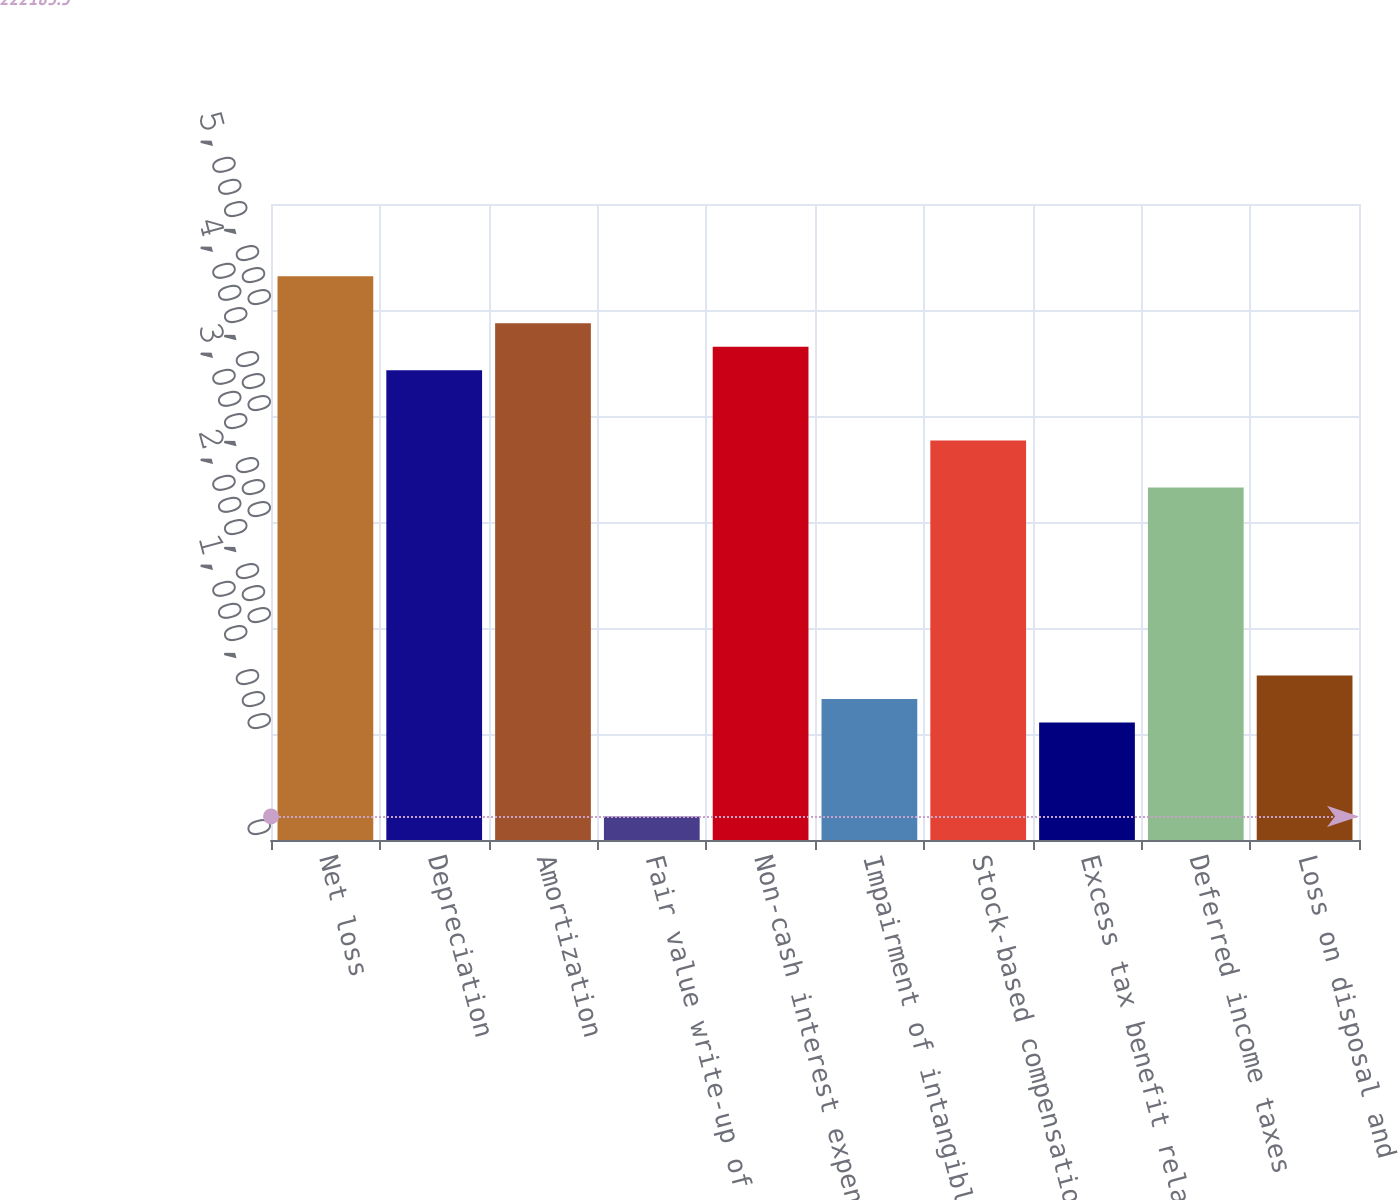Convert chart to OTSL. <chart><loc_0><loc_0><loc_500><loc_500><bar_chart><fcel>Net loss<fcel>Depreciation<fcel>Amortization<fcel>Fair value write-up of<fcel>Non-cash interest expense<fcel>Impairment of intangible<fcel>Stock-based compensation<fcel>Excess tax benefit related to<fcel>Deferred income taxes<fcel>Loss on disposal and<nl><fcel>5.31913e+06<fcel>4.43271e+06<fcel>4.87592e+06<fcel>222184<fcel>4.65431e+06<fcel>1.33022e+06<fcel>3.76789e+06<fcel>1.10861e+06<fcel>3.32467e+06<fcel>1.55182e+06<nl></chart> 